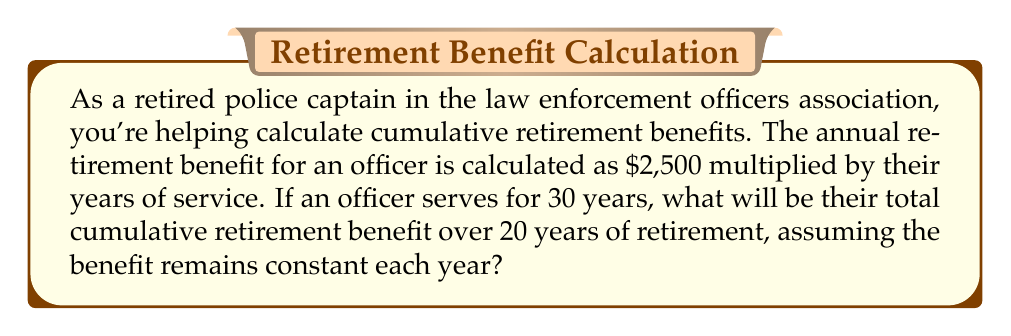Can you solve this math problem? Let's approach this step-by-step:

1) First, we need to calculate the annual retirement benefit:
   Annual benefit = $2,500 \times$ Years of service
   $$ \text{Annual benefit} = \$2,500 \times 30 = \$75,000 $$

2) Now, we need to find the cumulative benefit over 20 years. This is an arithmetic sequence where:
   - First term, $a_1 = \$75,000$
   - Number of terms, $n = 20$ (for 20 years of retirement)
   - Common difference, $d = 0$ (as the benefit remains constant each year)

3) For an arithmetic sequence, the sum of $n$ terms is given by:
   $$ S_n = \frac{n}{2}(a_1 + a_n) $$
   where $a_n$ is the last term.

4) Since the benefit is constant, $a_1 = a_n = \$75,000$

5) Substituting into the formula:
   $$ S_{20} = \frac{20}{2}(\$75,000 + \$75,000) = 10 \times \$150,000 = \$1,500,000 $$

Therefore, the cumulative retirement benefit over 20 years will be $1,500,000.
Answer: $1,500,000 